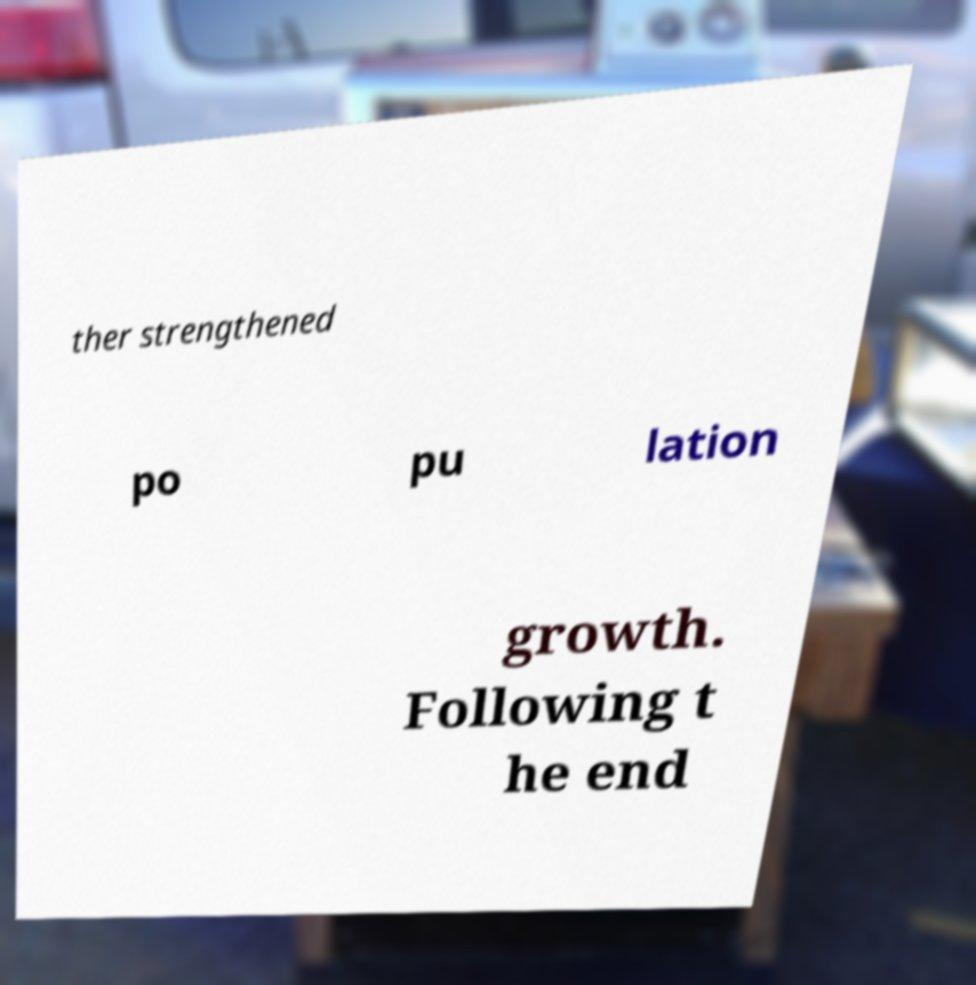Could you extract and type out the text from this image? ther strengthened po pu lation growth. Following t he end 